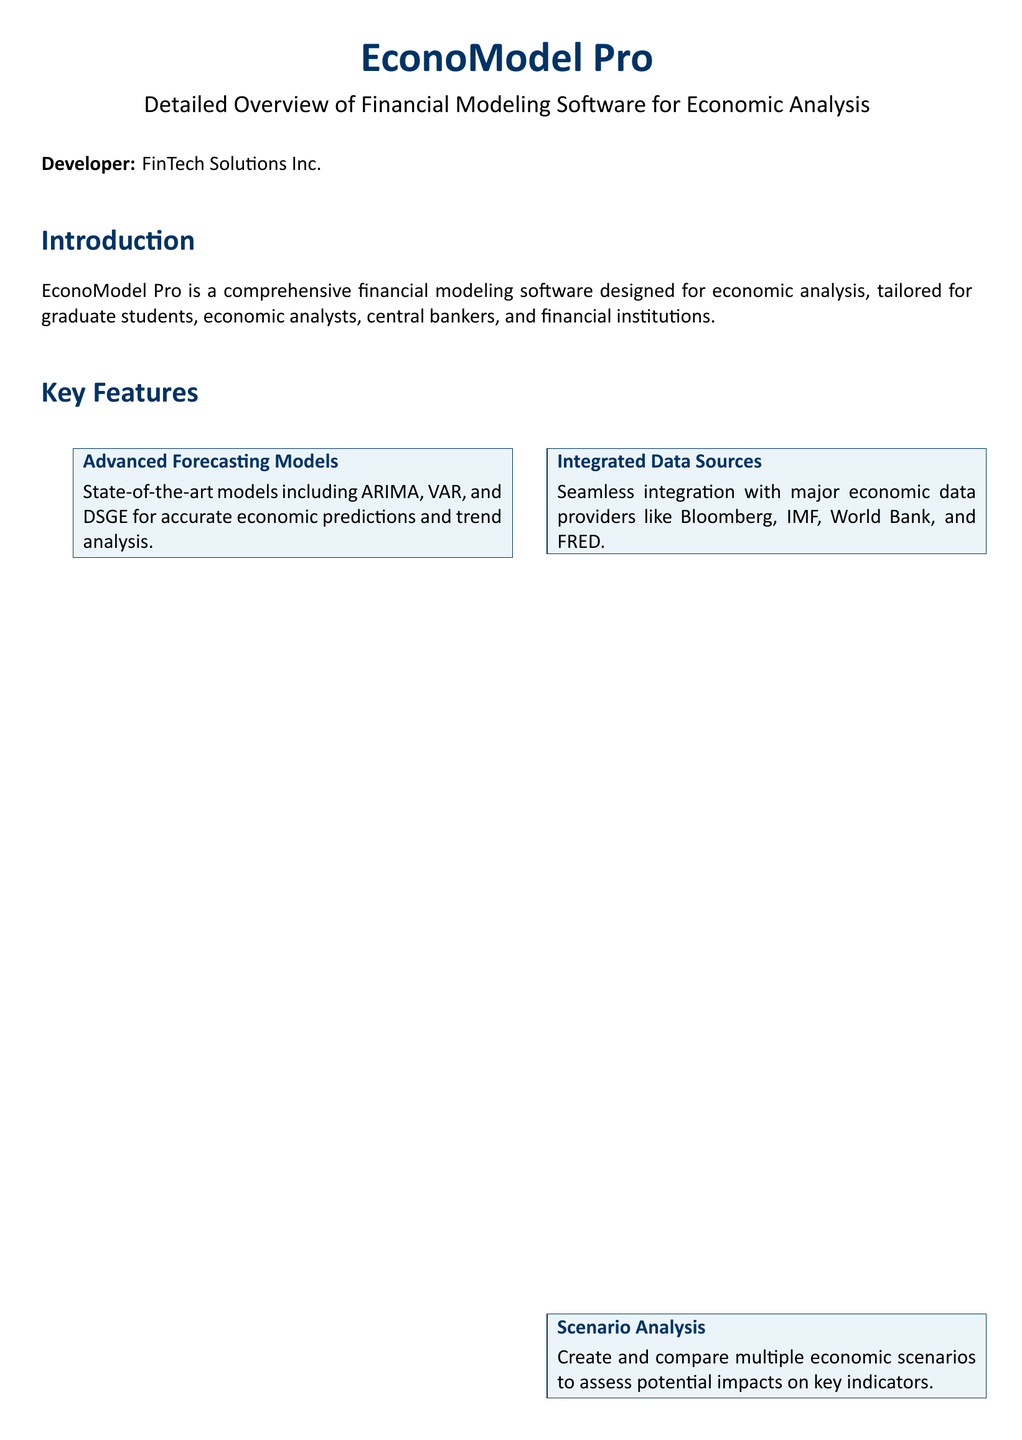What is the name of the software? The document specifies the software as "EconoModel Pro."
Answer: EconoModel Pro Who is the developer of the software? The document mentions "FinTech Solutions Inc." as the developer.
Answer: FinTech Solutions Inc What is the individual plan pricing? The document lists the individual plan pricing as $49.99 per month.
Answer: $49.99 per month What are the operating systems supported? The software supports Windows 10 or later and macOS 10.14 or later as mentioned in the document.
Answer: Windows 10 or later, macOS 10.14 or later What type of analysis can be performed with the software? The document highlights the ability to create and compare multiple economic scenarios for analysis.
Answer: Scenario Analysis How many GB of RAM is recommended for installation? The technical specifications recommend 8 GB of RAM for optimal performance.
Answer: 8 GB What are the main programming languages compatible with the software? The document lists R, Python, and MATLAB as compatible programming languages.
Answer: R, Python, MATLAB What type of customer support is available? The document outlines that support is available via email and phone.
Answer: Email and Phone What is the main benefit of using EconoModel Pro? The document emphasizes enhanced decision making as a key benefit.
Answer: Enhanced Decision Making 